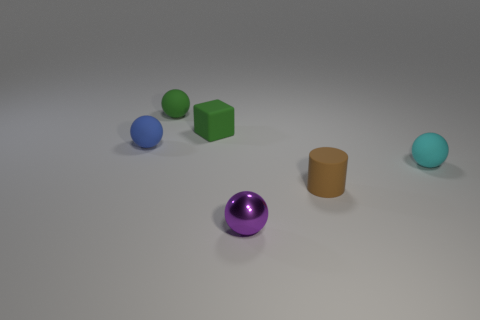What number of objects are either purple shiny objects or small blue metal balls?
Your response must be concise. 1. What is the green object on the right side of the tiny green rubber thing that is left of the small green cube made of?
Ensure brevity in your answer.  Rubber. Is there a small green block made of the same material as the cyan ball?
Offer a very short reply. Yes. What shape is the matte thing that is to the right of the rubber thing in front of the tiny rubber sphere that is in front of the blue rubber object?
Provide a succinct answer. Sphere. What material is the tiny purple thing?
Keep it short and to the point. Metal. The block that is made of the same material as the tiny cylinder is what color?
Your response must be concise. Green. There is a cyan matte sphere that is right of the small blue sphere; are there any brown rubber objects that are behind it?
Your response must be concise. No. What number of other objects are there of the same shape as the cyan object?
Provide a short and direct response. 3. Do the matte object in front of the small cyan matte ball and the tiny thing in front of the brown matte cylinder have the same shape?
Keep it short and to the point. No. How many cyan matte balls are behind the sphere that is on the left side of the tiny sphere that is behind the small green matte block?
Provide a short and direct response. 0. 